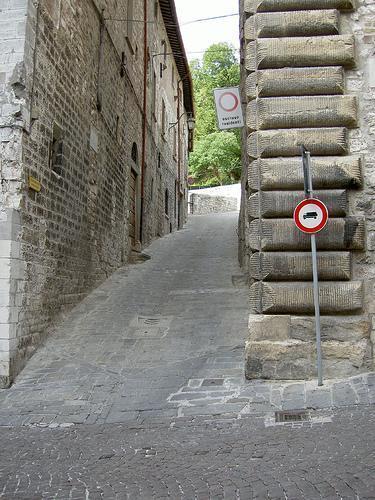How many signs are there?
Give a very brief answer. 3. 